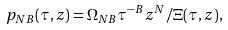Convert formula to latex. <formula><loc_0><loc_0><loc_500><loc_500>p _ { N B } ( \tau , z ) = \Omega _ { N B } \tau ^ { - B } z ^ { N } / \Xi ( \tau , z ) ,</formula> 